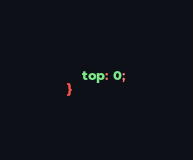Convert code to text. <code><loc_0><loc_0><loc_500><loc_500><_CSS_>    top: 0;
}

</code> 